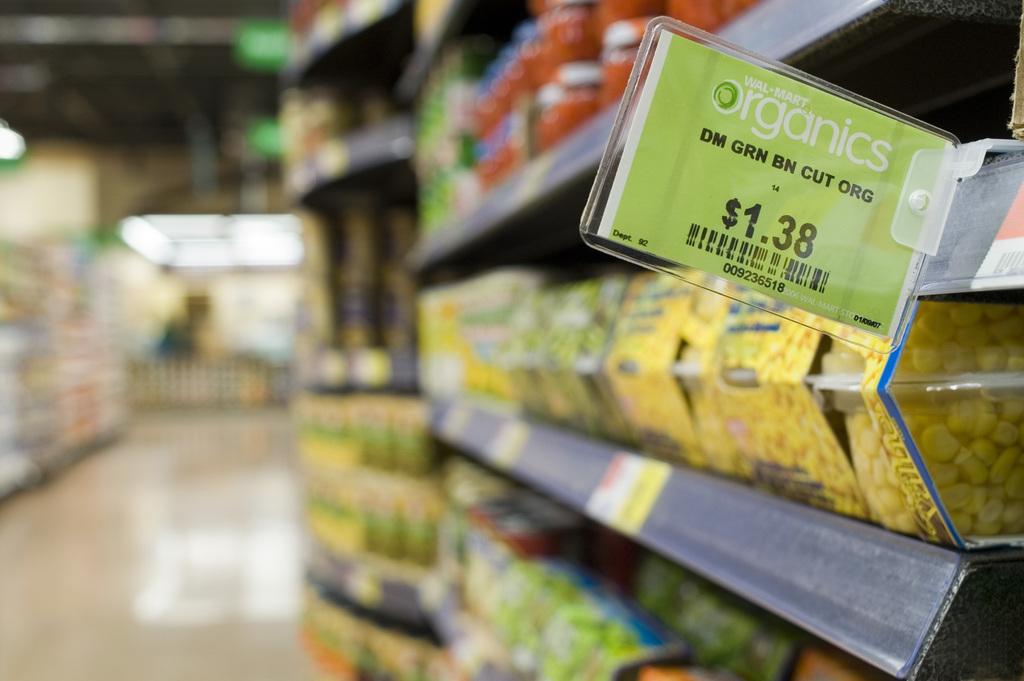How much is the organics?
Provide a short and direct response. $1.38. 